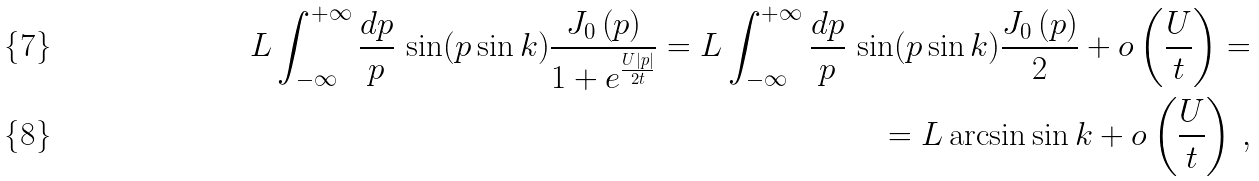Convert formula to latex. <formula><loc_0><loc_0><loc_500><loc_500>L \int _ { - \infty } ^ { + \infty } \frac { d p } { p } \, \sin ( p \sin k ) \frac { J _ { 0 } \left ( { p } \right ) } { 1 + e ^ { \frac { U | p | } { 2 t } } } = L \int _ { - \infty } ^ { + \infty } \frac { d p } { p } \, \sin ( p \sin k ) \frac { J _ { 0 } \left ( { p } \right ) } { 2 } + o \left ( \frac { U } { t } \right ) = \\ = L \arcsin \sin k + o \left ( \frac { U } { t } \right ) \, ,</formula> 